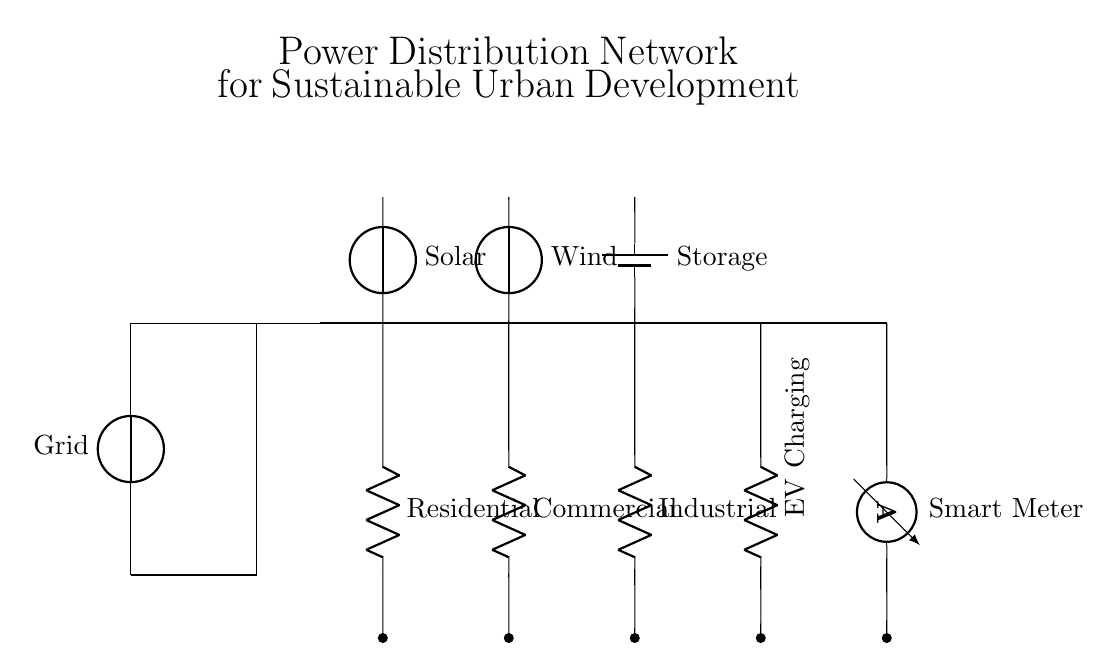What are the sources of energy in this circuit? The circuit diagram shows a grid, solar panels, and wind turbines as energy sources. These components are clearly labeled, indicating their function in the power distribution network.
Answer: grid, solar, wind What type of battery is used for storage? The circuit indicates a battery labeled as "Storage," which typically refers to a rechargeable battery system that stores energy for later use. Thus, it is identified as a general battery storage device.
Answer: Storage Which type of load is associated with the highest energy demand? From the circuit, the industrial load is typically associated with the highest power consumption, followed by commercial and residential loads. This understanding is based on common energy use patterns where industrial facilities have larger energy requirements.
Answer: Industrial How many types of loads are present in this circuit? The diagram shows three distinct loads: residential, commercial, and industrial. By counting these labels in the circuit connections, one can confirm the number of load types present.
Answer: Three What role does the smart meter play in the circuit? The smart meter is used to measure energy consumption in real-time, allowing for efficient energy management. Its presence near the end of the distribution network indicates its role in monitoring the output to consumers.
Answer: Measure energy How are the renewable energy sources connected to the power distribution network? The solar panels and wind turbines are connected directly to the bus bar, which distributes electricity to the various loads in the circuit. This connection is essential for integrating renewable energy into the overall power system.
Answer: Directly to bus bar 